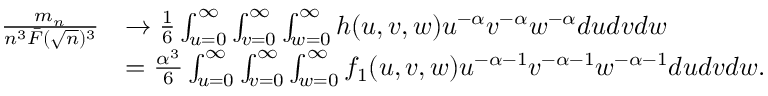<formula> <loc_0><loc_0><loc_500><loc_500>\begin{array} { r l } { \frac { m _ { n } } { n ^ { 3 } \bar { F } ( \sqrt { n } ) ^ { 3 } } } & { \rightarrow \frac { 1 } { 6 } \int _ { u = 0 } ^ { \infty } \int _ { v = 0 } ^ { \infty } \int _ { w = 0 } ^ { \infty } h ( u , v , w ) u ^ { - \alpha } v ^ { - \alpha } w ^ { - \alpha } d u d v d w } \\ & { = \frac { \alpha ^ { 3 } } { 6 } \int _ { u = 0 } ^ { \infty } \int _ { v = 0 } ^ { \infty } \int _ { w = 0 } ^ { \infty } f _ { 1 } ( u , v , w ) u ^ { - \alpha - 1 } v ^ { - \alpha - 1 } w ^ { - \alpha - 1 } d u d v d w . } \end{array}</formula> 